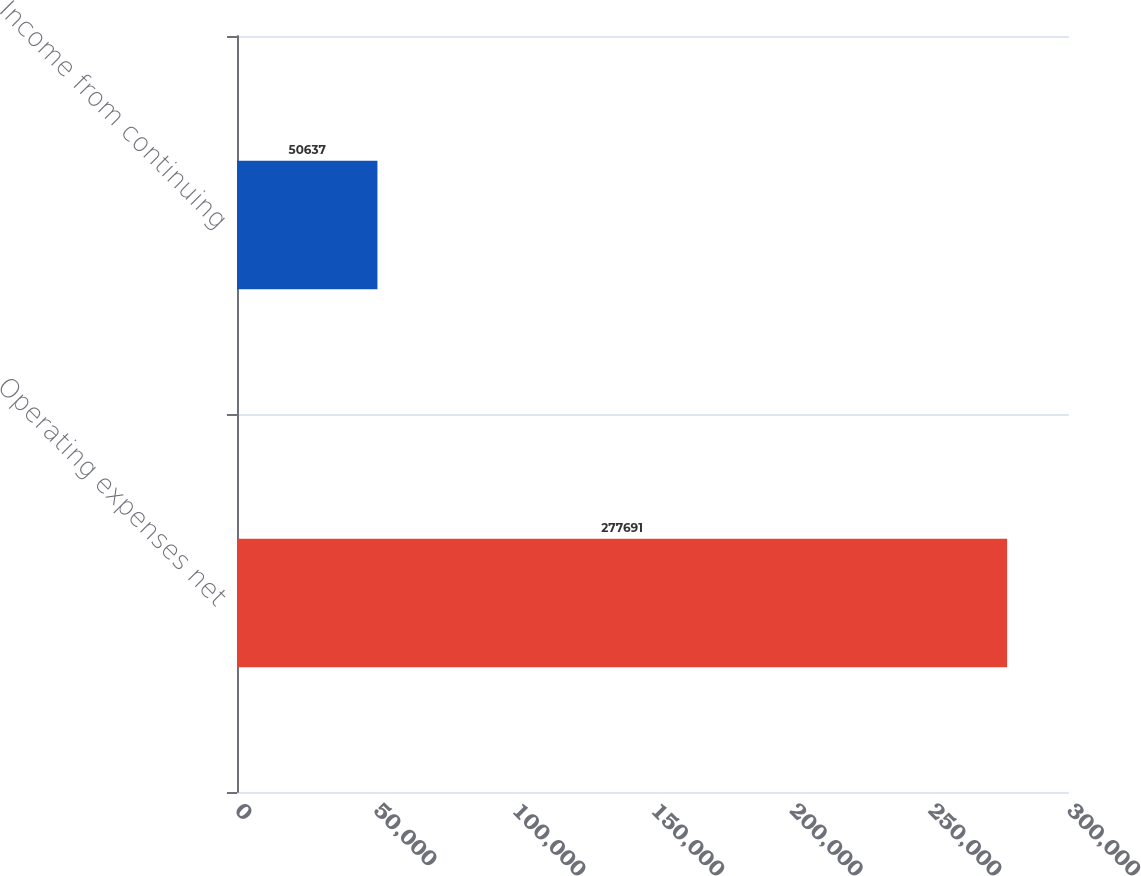<chart> <loc_0><loc_0><loc_500><loc_500><bar_chart><fcel>Operating expenses net<fcel>Income from continuing<nl><fcel>277691<fcel>50637<nl></chart> 